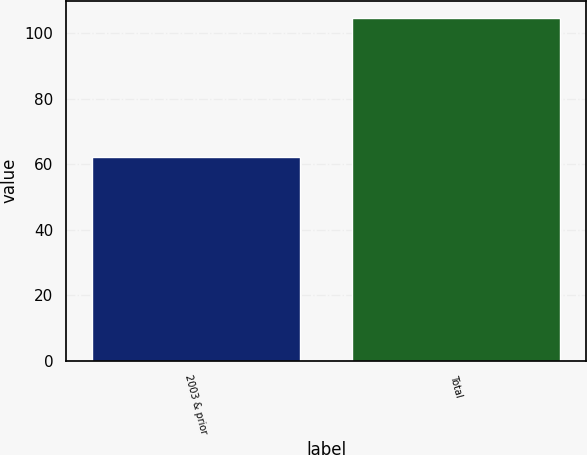<chart> <loc_0><loc_0><loc_500><loc_500><bar_chart><fcel>2003 & prior<fcel>Total<nl><fcel>62.3<fcel>104.7<nl></chart> 